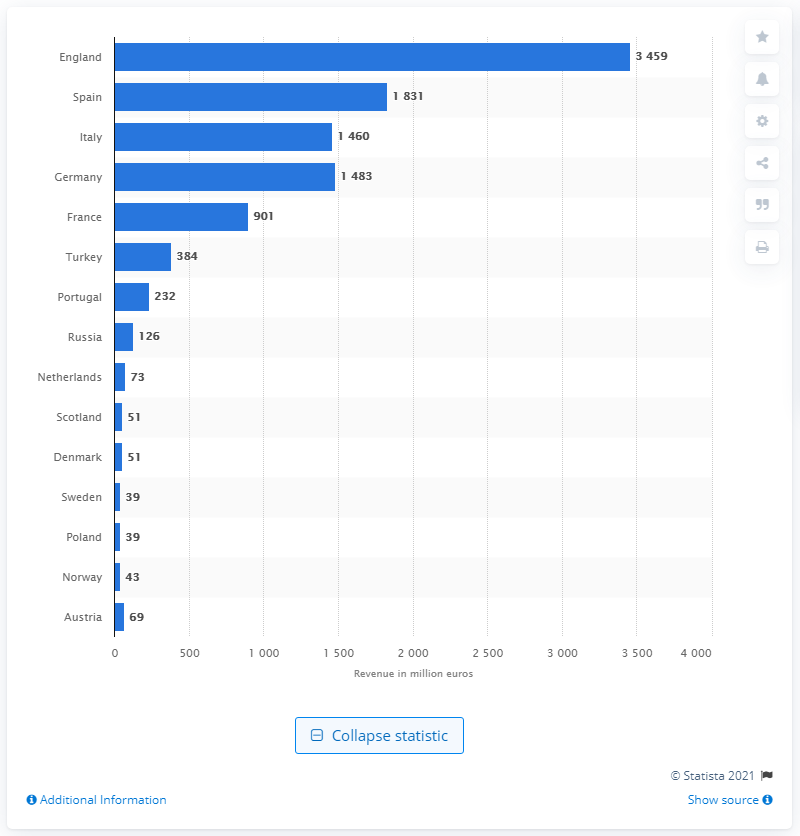Outline some significant characteristics in this image. The broadcasting revenues of the English Premier League in the 2018/19 season were approximately 34,590. 